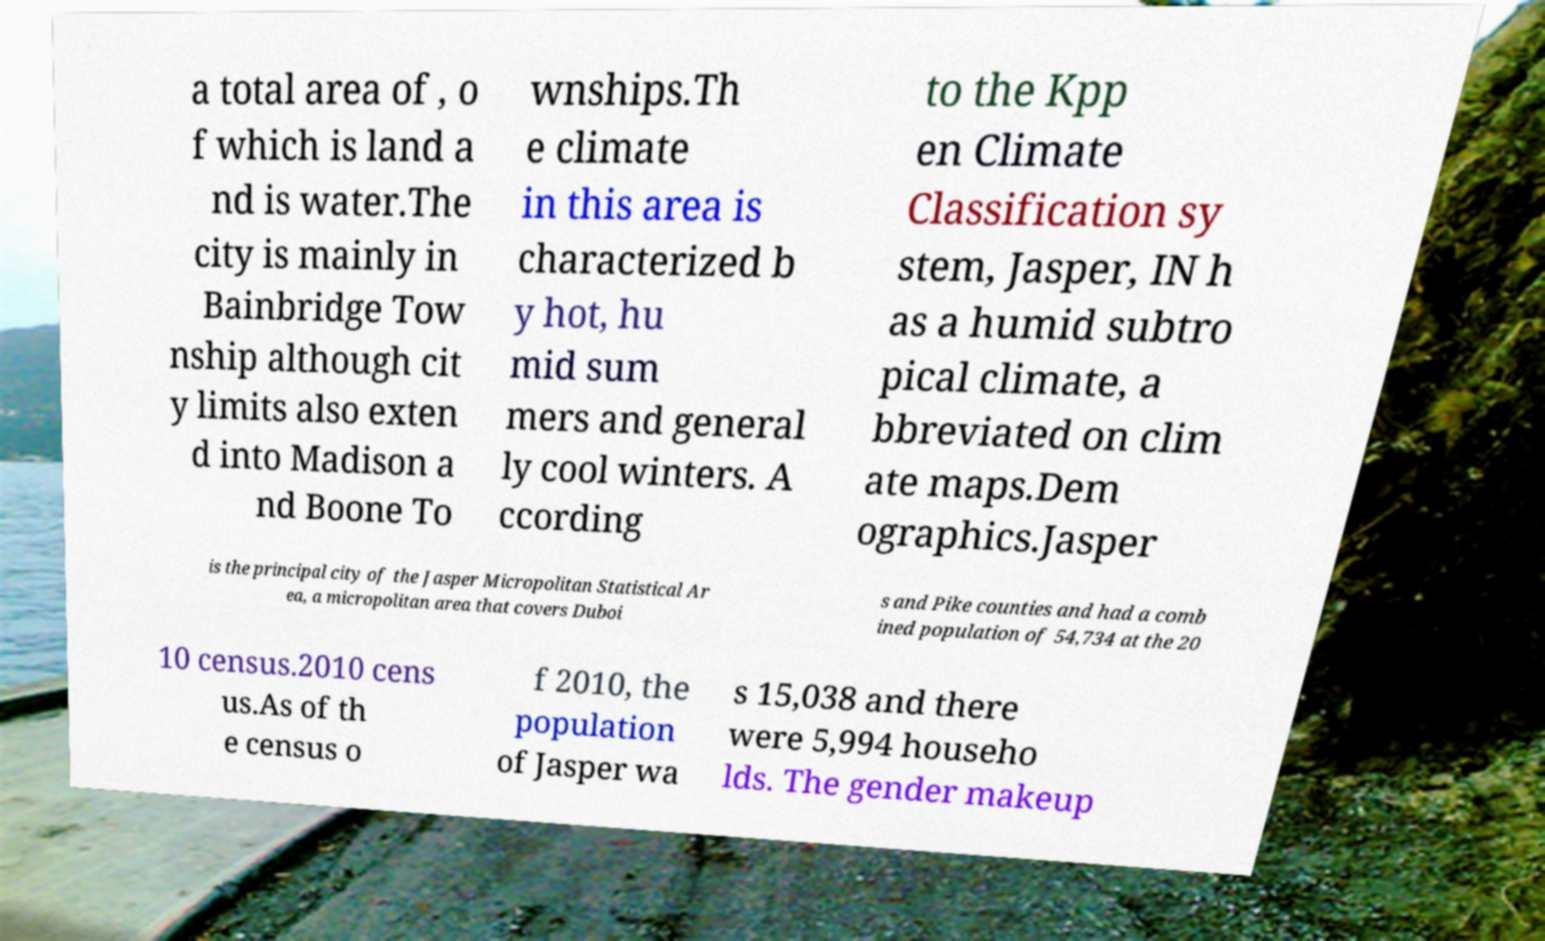What messages or text are displayed in this image? I need them in a readable, typed format. a total area of , o f which is land a nd is water.The city is mainly in Bainbridge Tow nship although cit y limits also exten d into Madison a nd Boone To wnships.Th e climate in this area is characterized b y hot, hu mid sum mers and general ly cool winters. A ccording to the Kpp en Climate Classification sy stem, Jasper, IN h as a humid subtro pical climate, a bbreviated on clim ate maps.Dem ographics.Jasper is the principal city of the Jasper Micropolitan Statistical Ar ea, a micropolitan area that covers Duboi s and Pike counties and had a comb ined population of 54,734 at the 20 10 census.2010 cens us.As of th e census o f 2010, the population of Jasper wa s 15,038 and there were 5,994 househo lds. The gender makeup 